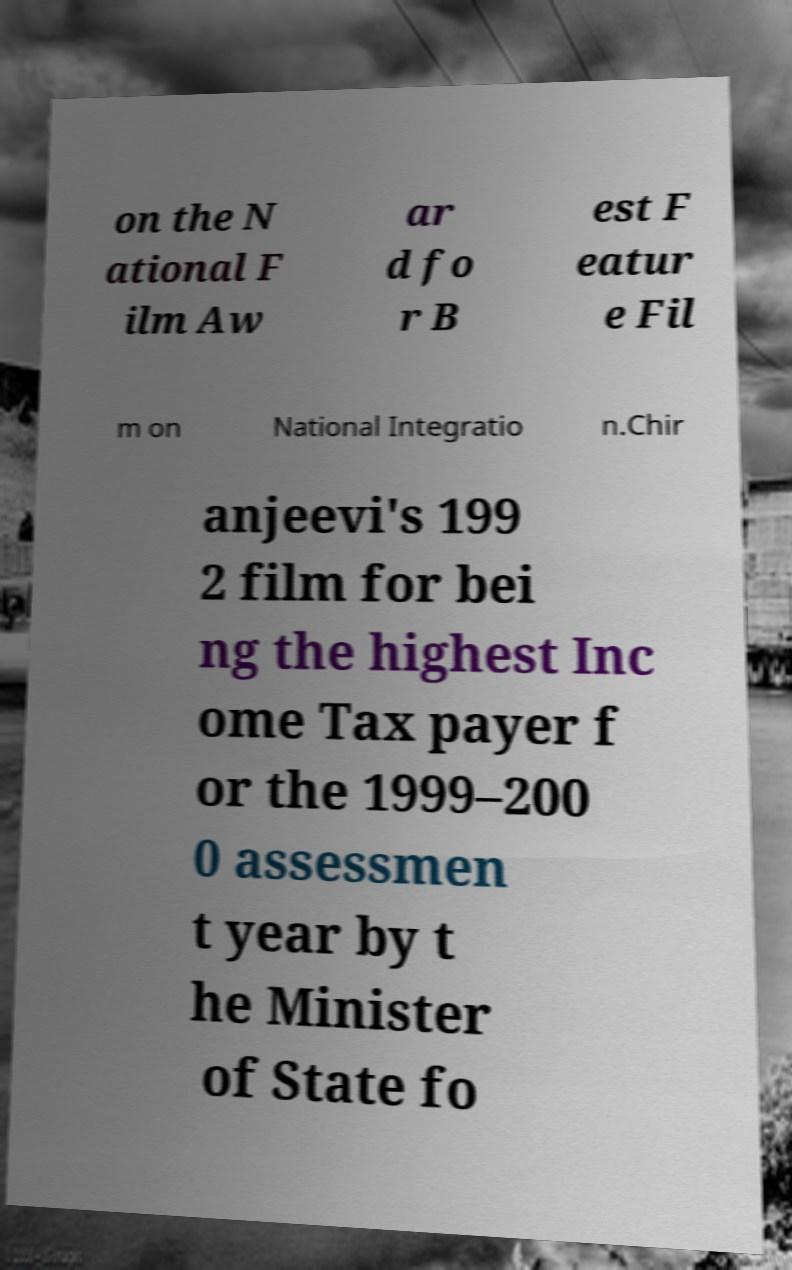What messages or text are displayed in this image? I need them in a readable, typed format. on the N ational F ilm Aw ar d fo r B est F eatur e Fil m on National Integratio n.Chir anjeevi's 199 2 film for bei ng the highest Inc ome Tax payer f or the 1999–200 0 assessmen t year by t he Minister of State fo 